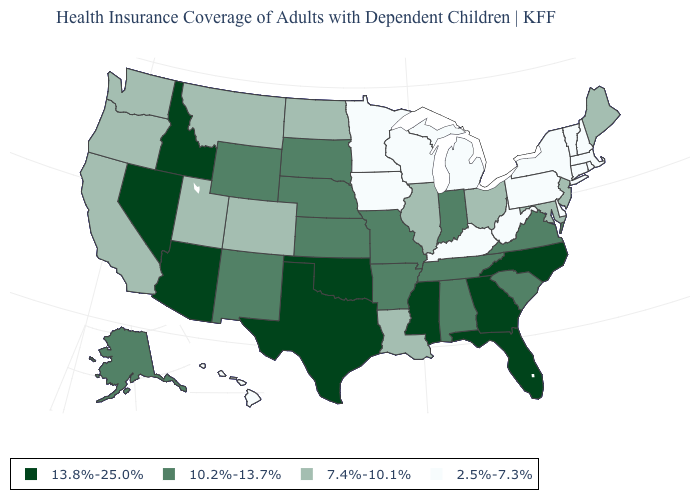Which states have the lowest value in the USA?
Keep it brief. Connecticut, Delaware, Hawaii, Iowa, Kentucky, Massachusetts, Michigan, Minnesota, New Hampshire, New York, Pennsylvania, Rhode Island, Vermont, West Virginia, Wisconsin. Among the states that border Vermont , which have the highest value?
Short answer required. Massachusetts, New Hampshire, New York. What is the value of Idaho?
Quick response, please. 13.8%-25.0%. What is the value of Maryland?
Answer briefly. 7.4%-10.1%. Does New Hampshire have the highest value in the Northeast?
Be succinct. No. Name the states that have a value in the range 13.8%-25.0%?
Quick response, please. Arizona, Florida, Georgia, Idaho, Mississippi, Nevada, North Carolina, Oklahoma, Texas. Does Arizona have the highest value in the USA?
Write a very short answer. Yes. Name the states that have a value in the range 13.8%-25.0%?
Answer briefly. Arizona, Florida, Georgia, Idaho, Mississippi, Nevada, North Carolina, Oklahoma, Texas. Does Ohio have the lowest value in the USA?
Quick response, please. No. What is the value of Michigan?
Concise answer only. 2.5%-7.3%. Does Kentucky have the lowest value in the USA?
Write a very short answer. Yes. What is the value of Tennessee?
Give a very brief answer. 10.2%-13.7%. What is the value of Indiana?
Quick response, please. 10.2%-13.7%. Name the states that have a value in the range 10.2%-13.7%?
Write a very short answer. Alabama, Alaska, Arkansas, Indiana, Kansas, Missouri, Nebraska, New Mexico, South Carolina, South Dakota, Tennessee, Virginia, Wyoming. Does Nebraska have the lowest value in the MidWest?
Concise answer only. No. 